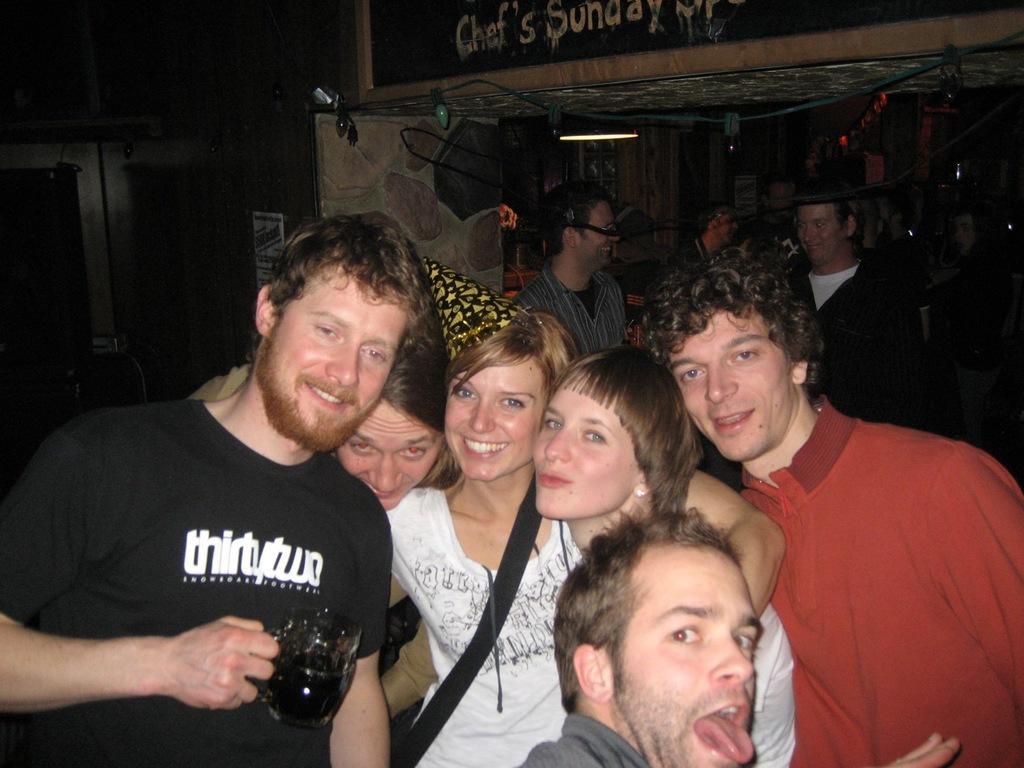Provide a one-sentence caption for the provided image. A group of people and one is wearing a black tshirt that says thirty two. 